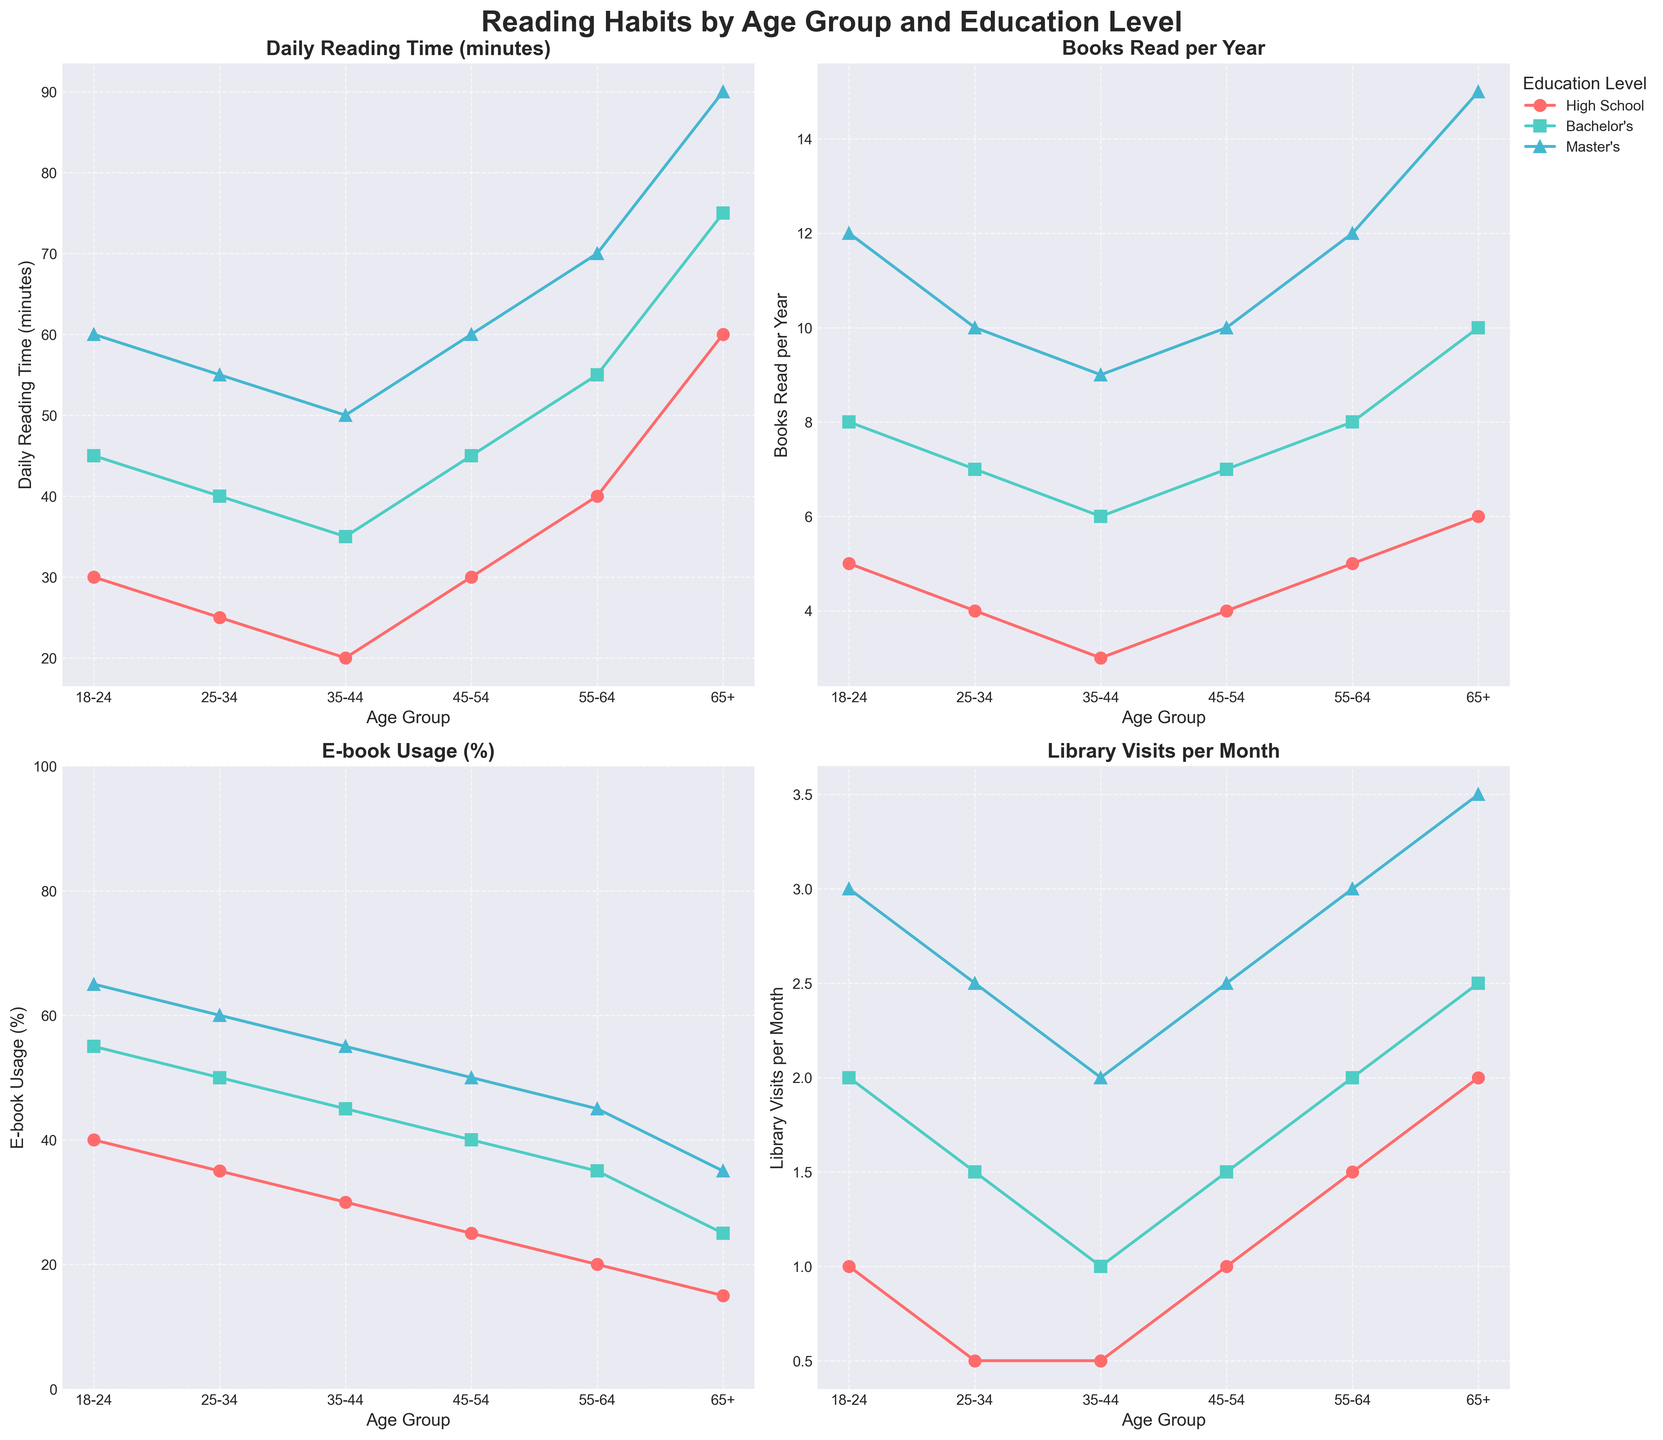What age group and education level has the highest daily reading time? To determine the highest daily reading time, examine the 'Daily Reading Time (minutes)' plot. Track the maximum y-axis value and the corresponding line. The highest value is present at age group '65+' with the 'Master's' level of education.
Answer: 65+, Master's Which education level shows the highest e-book usage for the age group 18-24? To identify the highest e-book usage in the age group 18-24, look at the 'E-book Usage (%)' plot. Notice the markers for the 18-24 age group and determine which one has the highest value. The 'Master's' line reaches the highest percentage.
Answer: Master's What is the difference in daily reading time between the 'High School' and 'Master’s' education levels for the 35-44 age group? Locate the 'Daily Reading Time (minutes)' plot and find the values for the 35-44 age group for both 'High School' and 'Master's' education levels. 'High School' reads 20 minutes, and 'Master's' reads 50 minutes. Calculate the difference: 50 - 20 = 30 minutes.
Answer: 30 minutes In which age group does the 'Bachelor's' education level have the most library visits per month? Examine the 'Library Visits per Month' subplot and look at the line for 'Bachelor's' across all age groups. Locate the highest value, which is in the 65+ age group with 2.5 visits per month.
Answer: 65+ How does the trend of books read per year compare between those with a Bachelor's and a Master's degree? Track both 'Bachelor's' and 'Master's' lines in the 'Books Read per Year' subplot. Both show upward trends as age increases, but the 'Master's' consistently reads more books per year compared to 'Bachelor's' in each age group.
Answer: Master's reads more consistently Which education level has the most significant change in e-book usage when moving from 45-54 to 55-64 age group? Investigate the 'E-book Usage (%)' plot. Focus on the transition from the 45-54 to the 55-64 age group for all education levels. The 'Bachelor's' level shows a noticeable change from 40% to 35%.
Answer: Bachelor's Which age group shows the lowest number of books read per year for those with a Master's degree? Look at the 'Books Read per Year' subplot, track the line for those with a Master's degree, and find the lowest point. The 18-24 age group reads 12 books, which is the minimum.
Answer: 18-24 How does the average daily reading time vary across all age groups for the high school level? Calculate the daily reading time by adding the values for 'High School' across all age groups (30 + 25 + 20 + 30 + 40 + 60) and divide by the number of age groups (6), which equals 205 / 6 ≈ 34.17 minutes.
Answer: Approximately 34.17 minutes Which education level is the highest for e-book usage for age group 55-64? Refer to the 'E-book Usage (%)' subplot. Look for the markers corresponding to the 55-64 age group across all education levels. 'Master’s' has the highest usage at 45%.
Answer: Master's 